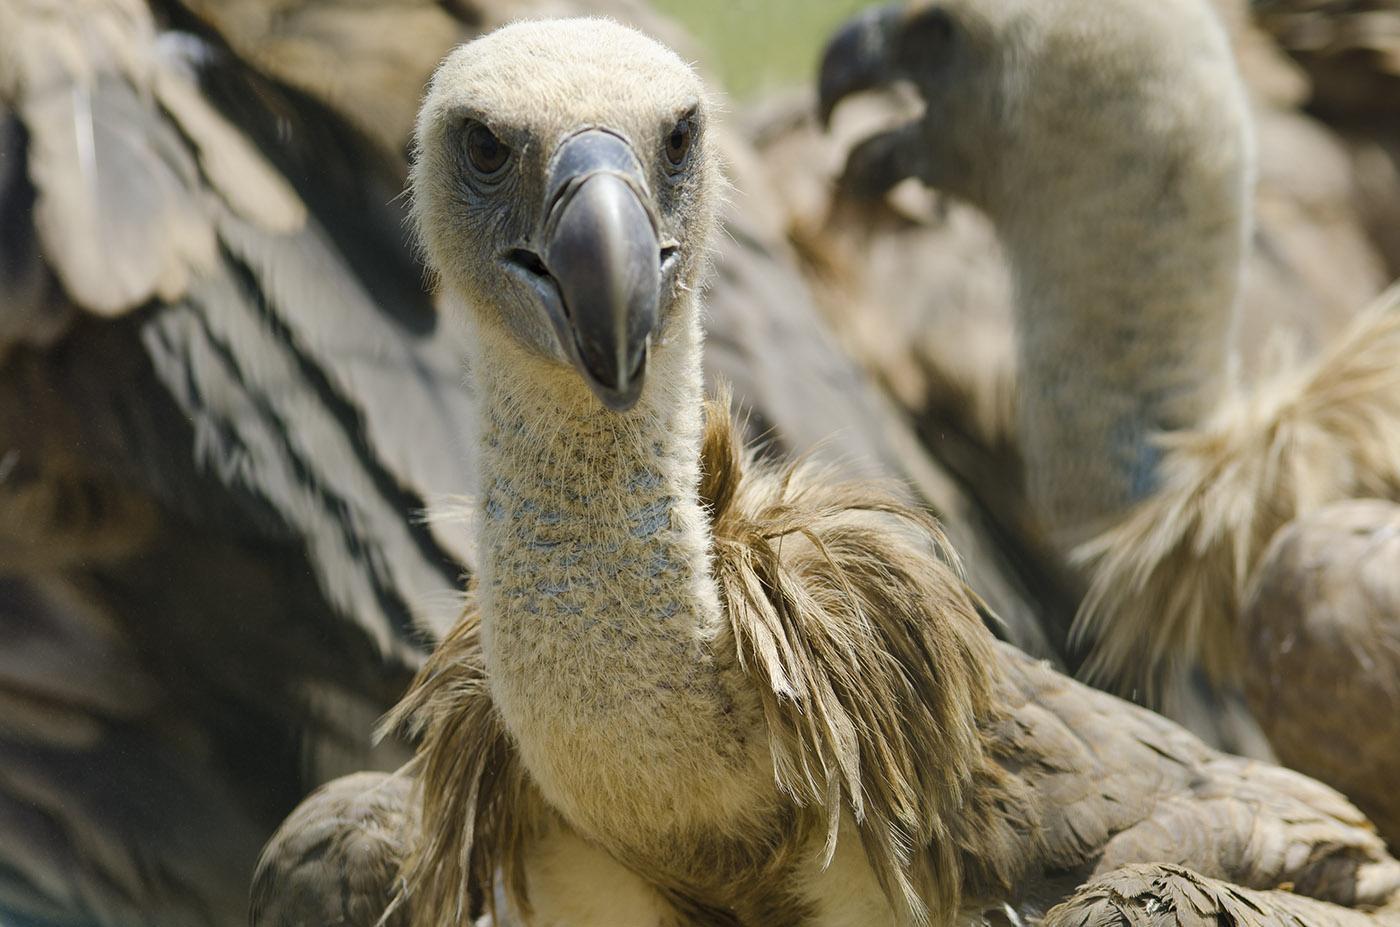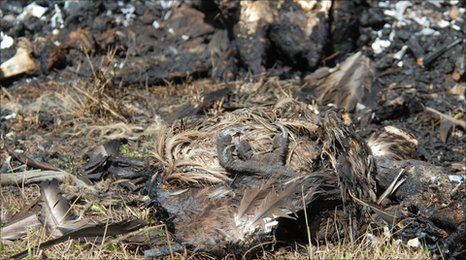The first image is the image on the left, the second image is the image on the right. Given the left and right images, does the statement "In at least one image there is a vulture white and black father flying into the ground with his beak open." hold true? Answer yes or no. No. The first image is the image on the left, the second image is the image on the right. Examine the images to the left and right. Is the description "The left image contains a carcass being eaten by vultures." accurate? Answer yes or no. No. 